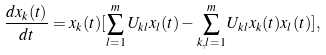Convert formula to latex. <formula><loc_0><loc_0><loc_500><loc_500>\frac { d x _ { k } ( t ) } { d t } = x _ { k } ( t ) [ \sum _ { l = 1 } ^ { m } U _ { k l } x _ { l } ( t ) - \sum _ { k , l = 1 } ^ { m } U _ { k l } x _ { k } ( t ) x _ { l } ( t ) ] ,</formula> 